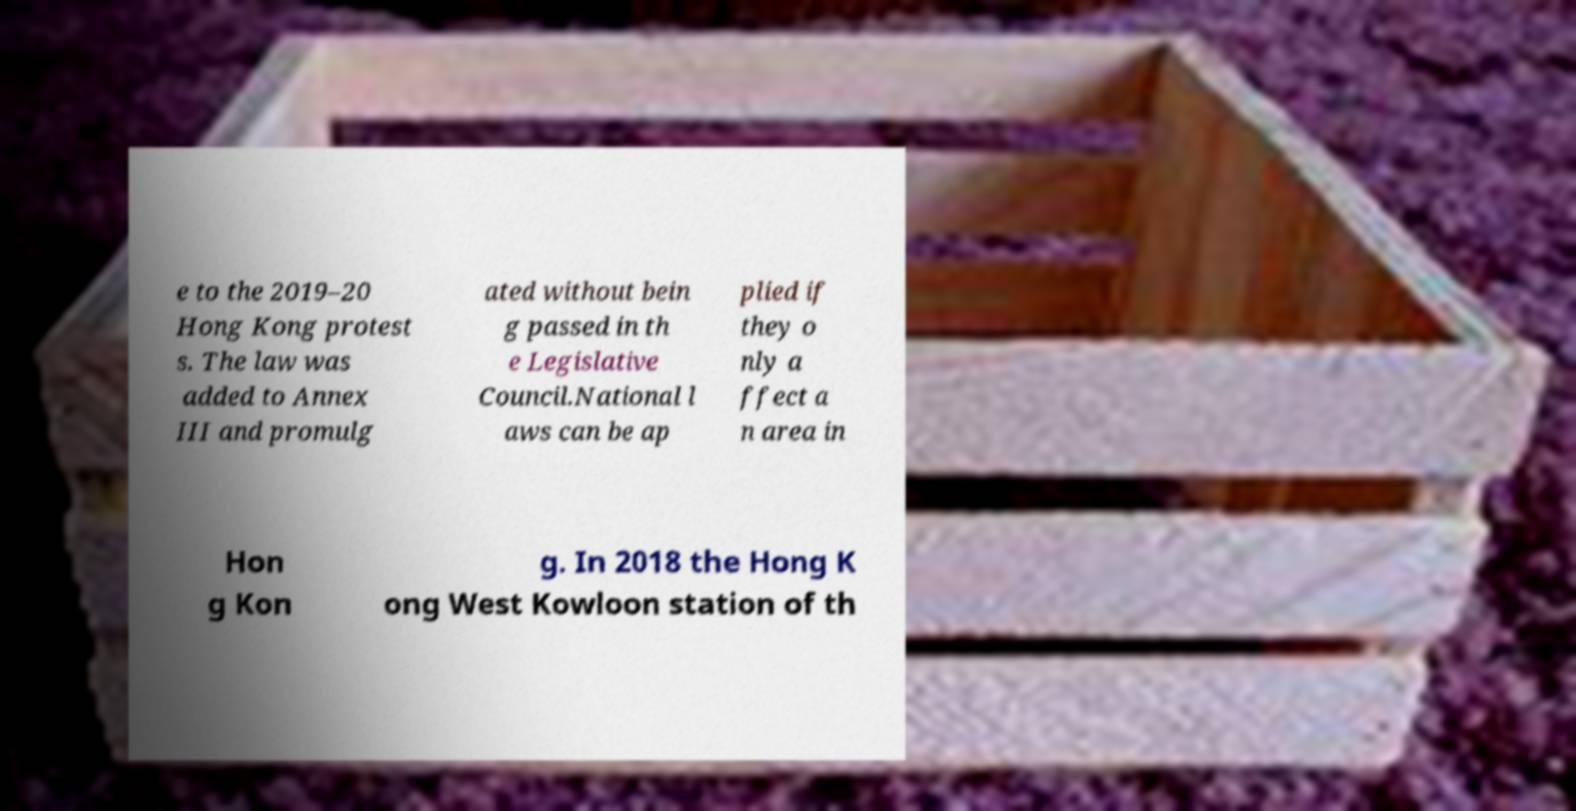Could you assist in decoding the text presented in this image and type it out clearly? e to the 2019–20 Hong Kong protest s. The law was added to Annex III and promulg ated without bein g passed in th e Legislative Council.National l aws can be ap plied if they o nly a ffect a n area in Hon g Kon g. In 2018 the Hong K ong West Kowloon station of th 